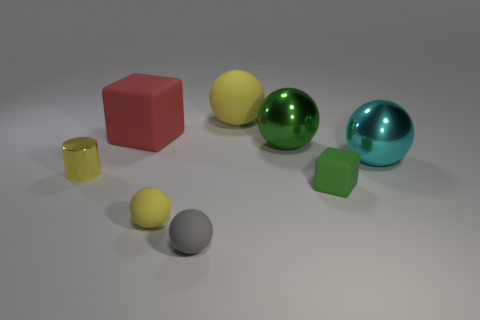Subtract 1 balls. How many balls are left? 4 Subtract all cyan spheres. How many spheres are left? 4 Subtract all brown cylinders. Subtract all green blocks. How many cylinders are left? 1 Add 2 yellow objects. How many objects exist? 10 Subtract all cylinders. How many objects are left? 7 Add 1 green shiny cubes. How many green shiny cubes exist? 1 Subtract 0 cyan cylinders. How many objects are left? 8 Subtract all yellow cylinders. Subtract all tiny metallic things. How many objects are left? 6 Add 6 small shiny cylinders. How many small shiny cylinders are left? 7 